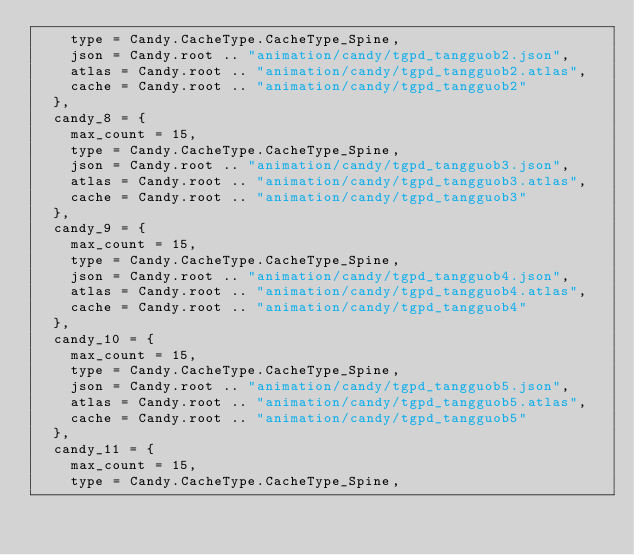<code> <loc_0><loc_0><loc_500><loc_500><_Lua_>		type = Candy.CacheType.CacheType_Spine,
		json = Candy.root .. "animation/candy/tgpd_tangguob2.json",
		atlas = Candy.root .. "animation/candy/tgpd_tangguob2.atlas",
		cache = Candy.root .. "animation/candy/tgpd_tangguob2"
	},
	candy_8 = {
		max_count = 15,
		type = Candy.CacheType.CacheType_Spine,
		json = Candy.root .. "animation/candy/tgpd_tangguob3.json",
		atlas = Candy.root .. "animation/candy/tgpd_tangguob3.atlas",
		cache = Candy.root .. "animation/candy/tgpd_tangguob3"
	},
	candy_9 = {
		max_count = 15,
		type = Candy.CacheType.CacheType_Spine,
		json = Candy.root .. "animation/candy/tgpd_tangguob4.json",
		atlas = Candy.root .. "animation/candy/tgpd_tangguob4.atlas",
		cache = Candy.root .. "animation/candy/tgpd_tangguob4"
	},
	candy_10 = {
		max_count = 15,
		type = Candy.CacheType.CacheType_Spine,
		json = Candy.root .. "animation/candy/tgpd_tangguob5.json",
		atlas = Candy.root .. "animation/candy/tgpd_tangguob5.atlas",
		cache = Candy.root .. "animation/candy/tgpd_tangguob5"
	},
	candy_11 = {
		max_count = 15,
		type = Candy.CacheType.CacheType_Spine,</code> 